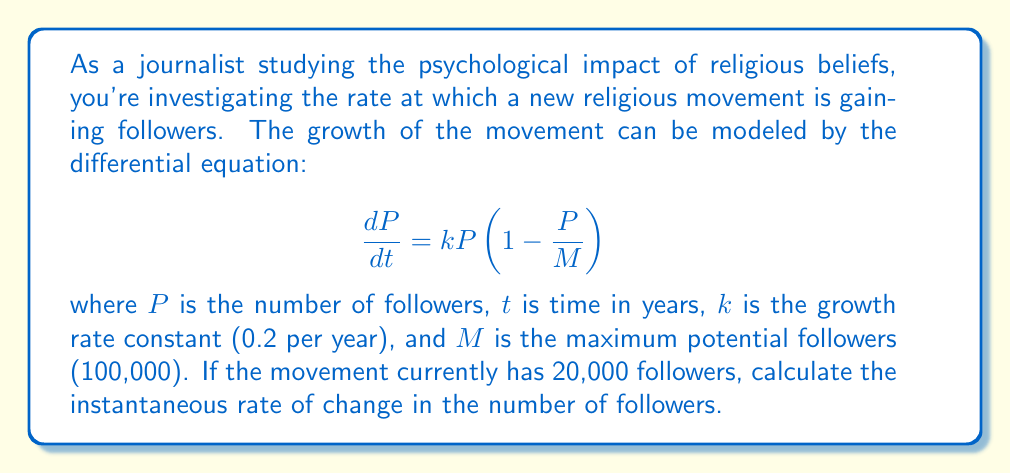Solve this math problem. To solve this problem, we need to use the given differential equation and substitute the known values:

1) The equation is: $\frac{dP}{dt} = kP(1-\frac{P}{M})$

2) We know:
   $k = 0.2$ per year
   $M = 100,000$ followers
   $P = 20,000$ followers (current)

3) Substitute these values into the equation:

   $\frac{dP}{dt} = 0.2 \cdot 20,000 \cdot (1-\frac{20,000}{100,000})$

4) Simplify:
   $\frac{dP}{dt} = 4,000 \cdot (1-0.2)$
   $\frac{dP}{dt} = 4,000 \cdot 0.8$
   $\frac{dP}{dt} = 3,200$

5) Therefore, the instantaneous rate of change is 3,200 followers per year.

This result indicates that at the current point in time, with 20,000 followers, the movement is gaining approximately 3,200 new followers per year. This rate will change as the number of followers increases, eventually slowing down as it approaches the maximum potential of 100,000 followers.
Answer: The instantaneous rate of change in the number of followers is 3,200 followers per year. 